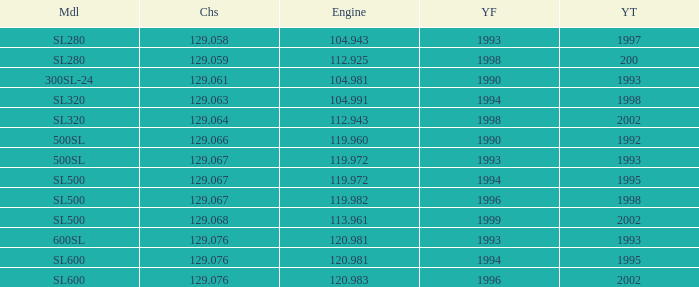Can you give me this table as a dict? {'header': ['Mdl', 'Chs', 'Engine', 'YF', 'YT'], 'rows': [['SL280', '129.058', '104.943', '1993', '1997'], ['SL280', '129.059', '112.925', '1998', '200'], ['300SL-24', '129.061', '104.981', '1990', '1993'], ['SL320', '129.063', '104.991', '1994', '1998'], ['SL320', '129.064', '112.943', '1998', '2002'], ['500SL', '129.066', '119.960', '1990', '1992'], ['500SL', '129.067', '119.972', '1993', '1993'], ['SL500', '129.067', '119.972', '1994', '1995'], ['SL500', '129.067', '119.982', '1996', '1998'], ['SL500', '129.068', '113.961', '1999', '2002'], ['600SL', '129.076', '120.981', '1993', '1993'], ['SL600', '129.076', '120.981', '1994', '1995'], ['SL600', '129.076', '120.983', '1996', '2002']]} Which Engine has a Model of sl500, and a Chassis smaller than 129.067? None. 